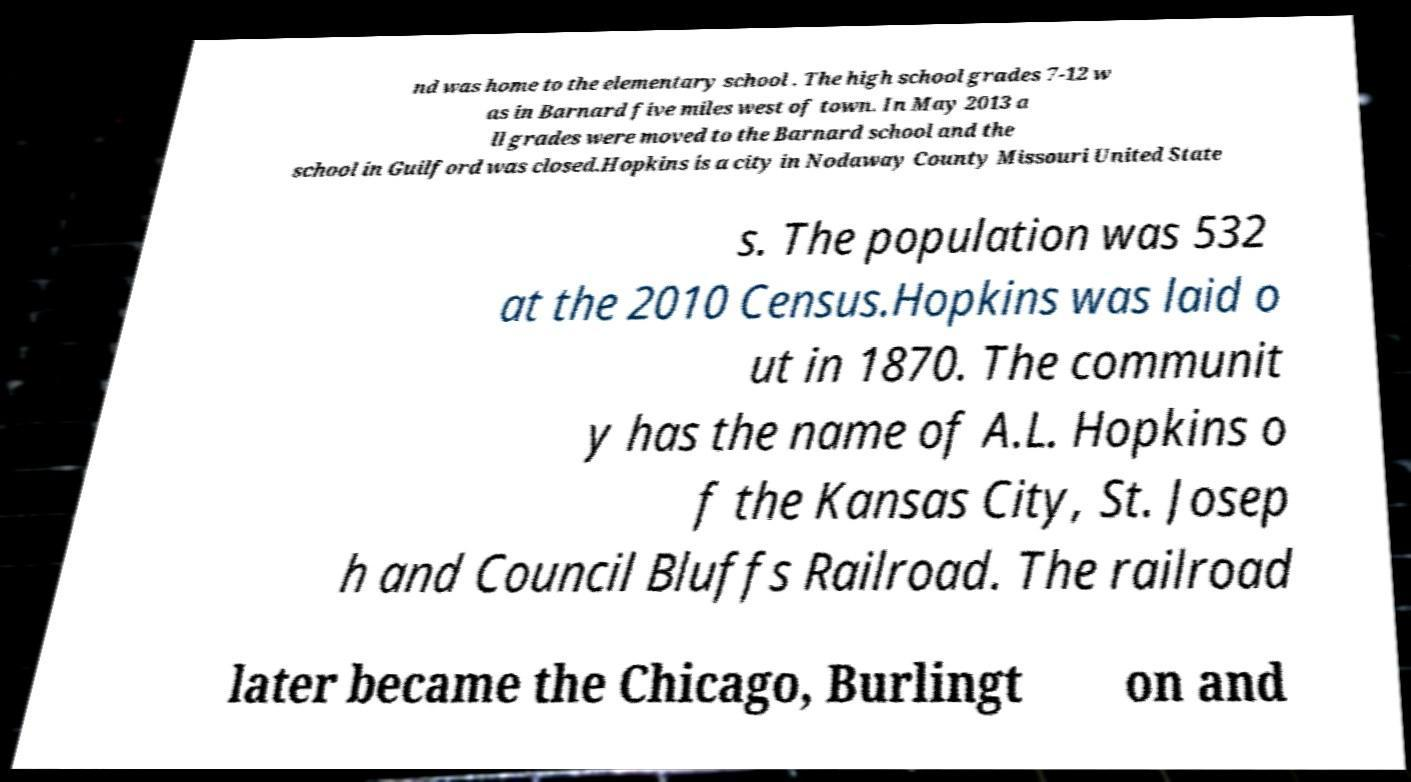Could you assist in decoding the text presented in this image and type it out clearly? nd was home to the elementary school . The high school grades 7-12 w as in Barnard five miles west of town. In May 2013 a ll grades were moved to the Barnard school and the school in Guilford was closed.Hopkins is a city in Nodaway County Missouri United State s. The population was 532 at the 2010 Census.Hopkins was laid o ut in 1870. The communit y has the name of A.L. Hopkins o f the Kansas City, St. Josep h and Council Bluffs Railroad. The railroad later became the Chicago, Burlingt on and 